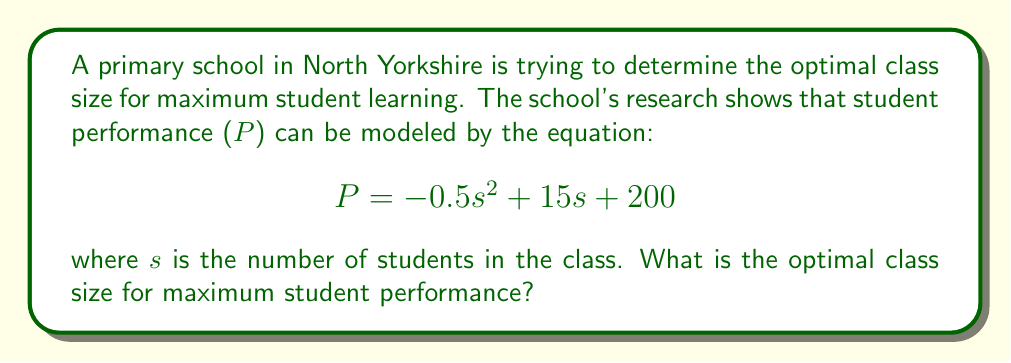Show me your answer to this math problem. To find the optimal class size for maximum student performance, we need to find the maximum value of the function $P(s)$. This can be done by following these steps:

1. The function given is a quadratic function in the form of $f(x) = ax^2 + bx + c$, where:
   $a = -0.5$
   $b = 15$
   $c = 200$

2. For a quadratic function, the maximum (or minimum) occurs at the vertex. The s-coordinate of the vertex can be found using the formula:

   $$s = -\frac{b}{2a}$$

3. Substituting the values:

   $$s = -\frac{15}{2(-0.5)} = \frac{15}{1} = 15$$

4. To verify this is a maximum (not a minimum), we can check that $a < 0$, which it is in this case ($a = -0.5$).

5. Since $s$ represents the number of students, we need to round to the nearest whole number. In this case, 15 is already a whole number.

Therefore, the optimal class size for maximum student performance is 15 students.
Answer: 15 students 